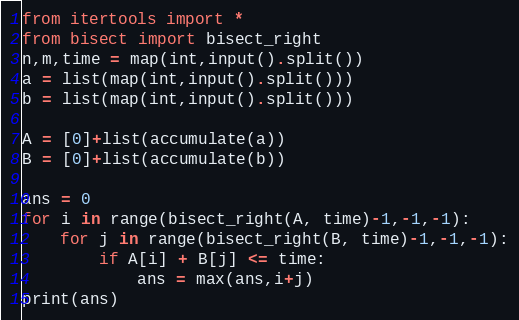<code> <loc_0><loc_0><loc_500><loc_500><_Python_>from itertools import *
from bisect import bisect_right
n,m,time = map(int,input().split())
a = list(map(int,input().split()))
b = list(map(int,input().split()))

A = [0]+list(accumulate(a))
B = [0]+list(accumulate(b))

ans = 0
for i in range(bisect_right(A, time)-1,-1,-1):
    for j in range(bisect_right(B, time)-1,-1,-1):
        if A[i] + B[j] <= time:
            ans = max(ans,i+j)
print(ans)
</code> 